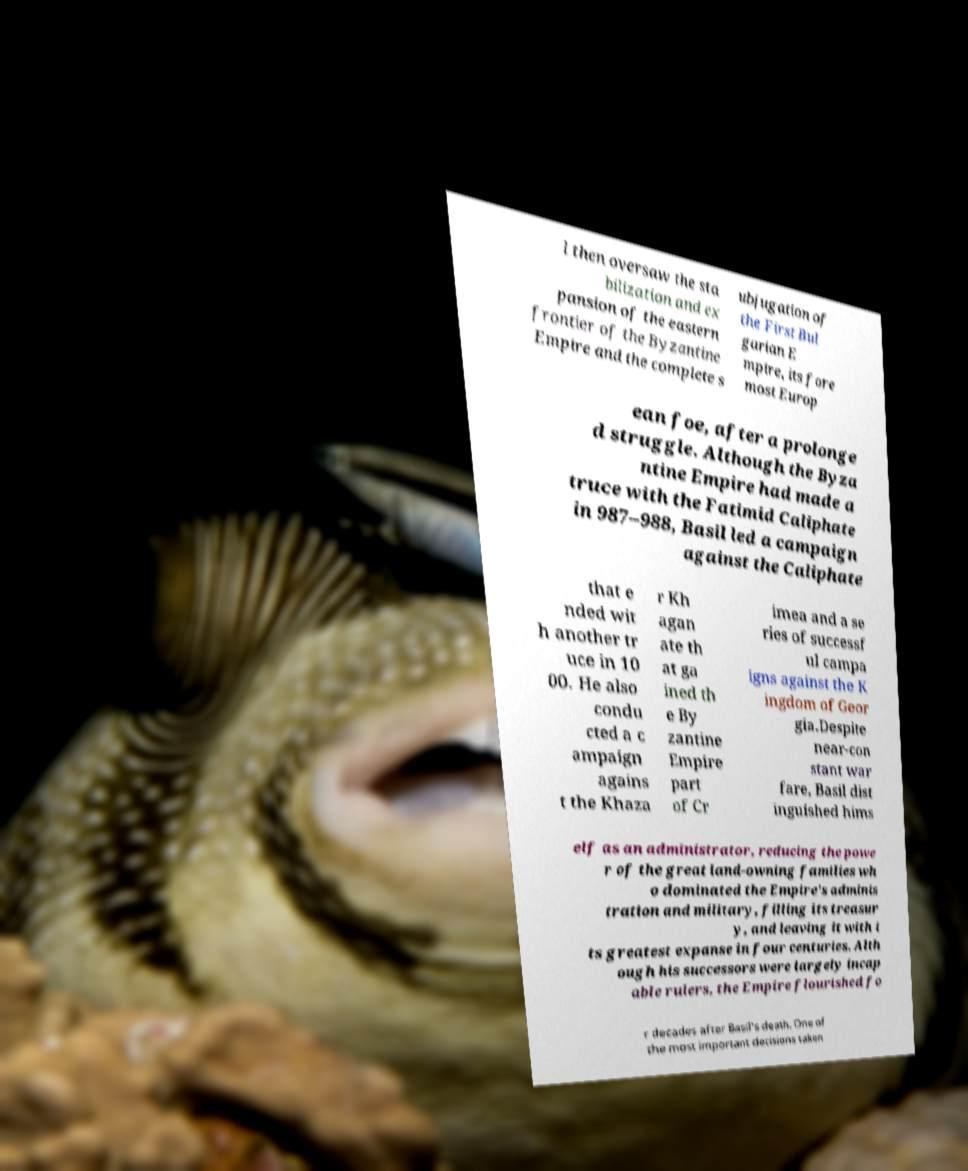Can you accurately transcribe the text from the provided image for me? l then oversaw the sta bilization and ex pansion of the eastern frontier of the Byzantine Empire and the complete s ubjugation of the First Bul garian E mpire, its fore most Europ ean foe, after a prolonge d struggle. Although the Byza ntine Empire had made a truce with the Fatimid Caliphate in 987–988, Basil led a campaign against the Caliphate that e nded wit h another tr uce in 10 00. He also condu cted a c ampaign agains t the Khaza r Kh agan ate th at ga ined th e By zantine Empire part of Cr imea and a se ries of successf ul campa igns against the K ingdom of Geor gia.Despite near-con stant war fare, Basil dist inguished hims elf as an administrator, reducing the powe r of the great land-owning families wh o dominated the Empire's adminis tration and military, filling its treasur y, and leaving it with i ts greatest expanse in four centuries. Alth ough his successors were largely incap able rulers, the Empire flourished fo r decades after Basil's death. One of the most important decisions taken 